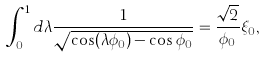Convert formula to latex. <formula><loc_0><loc_0><loc_500><loc_500>\int ^ { 1 } _ { 0 } d \lambda \frac { 1 } { \sqrt { \cos ( \lambda \phi _ { 0 } ) - \cos \phi _ { 0 } } } = \frac { \sqrt { 2 } } { \phi _ { 0 } } \xi _ { 0 } ,</formula> 